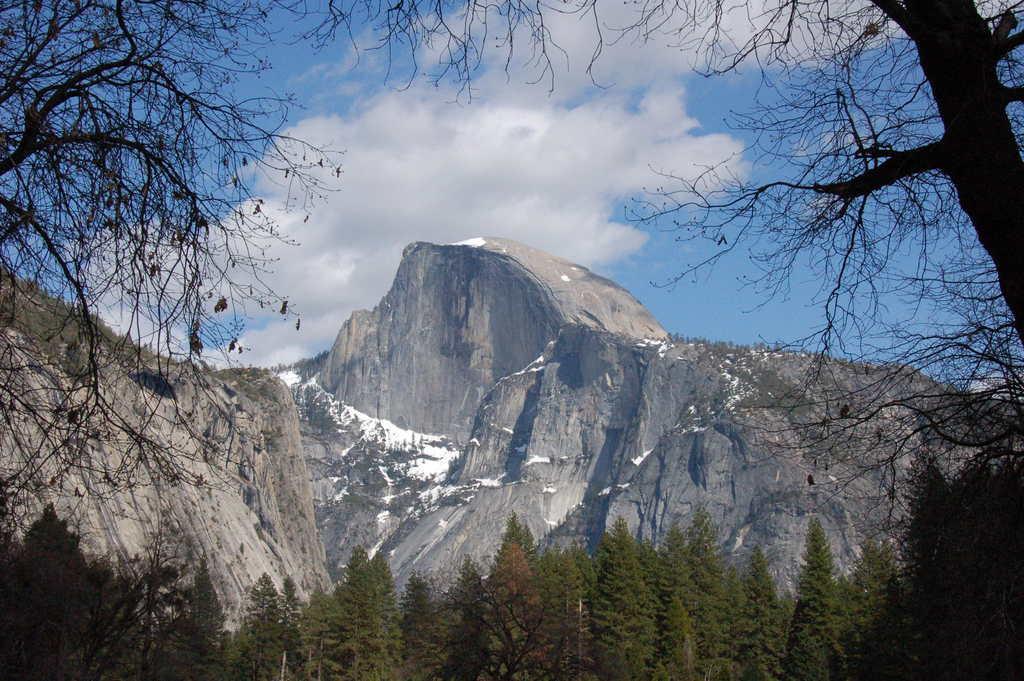Describe this image in one or two sentences. This image is taken outdoors. At the top of the image there is a sky with clouds. At the bottom of the image there are many trees. In the background there is a hill with a few trees and plants. 